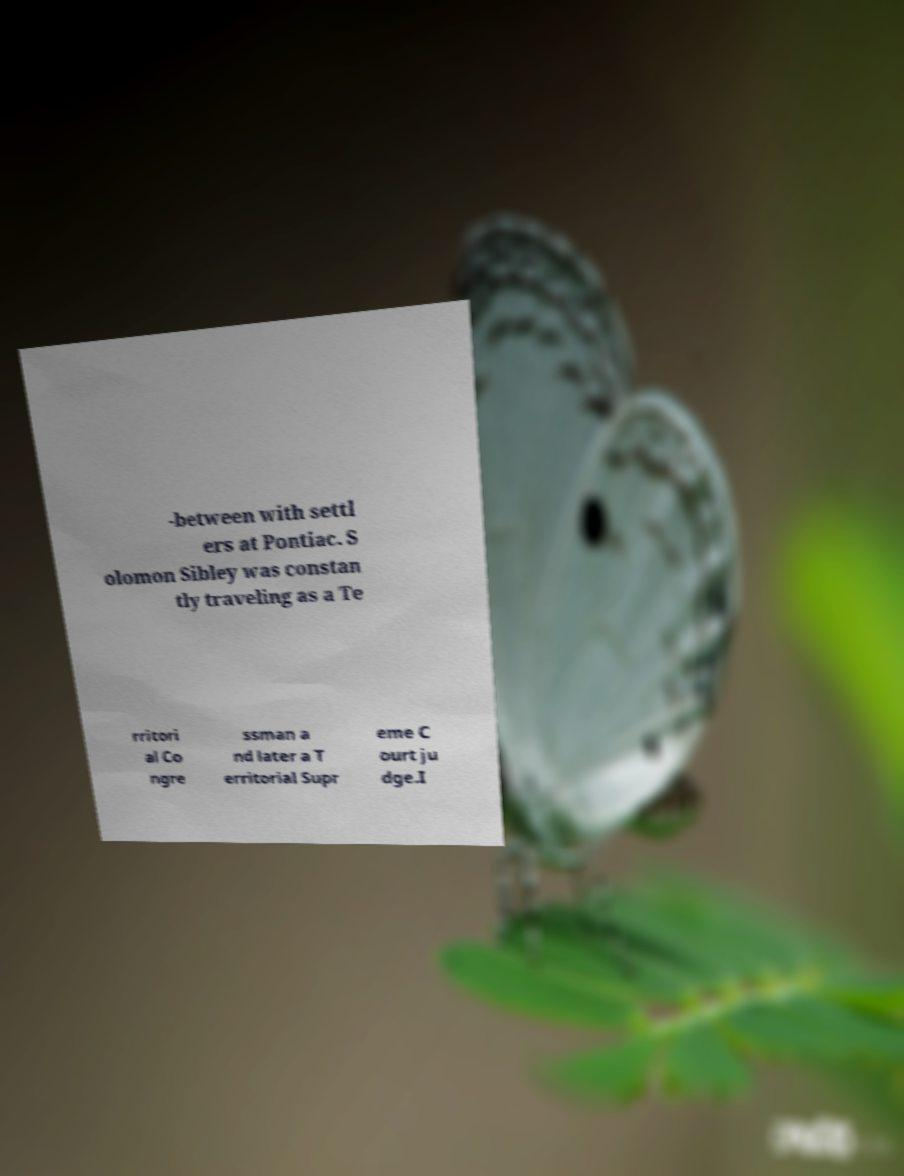I need the written content from this picture converted into text. Can you do that? -between with settl ers at Pontiac. S olomon Sibley was constan tly traveling as a Te rritori al Co ngre ssman a nd later a T erritorial Supr eme C ourt ju dge.I 